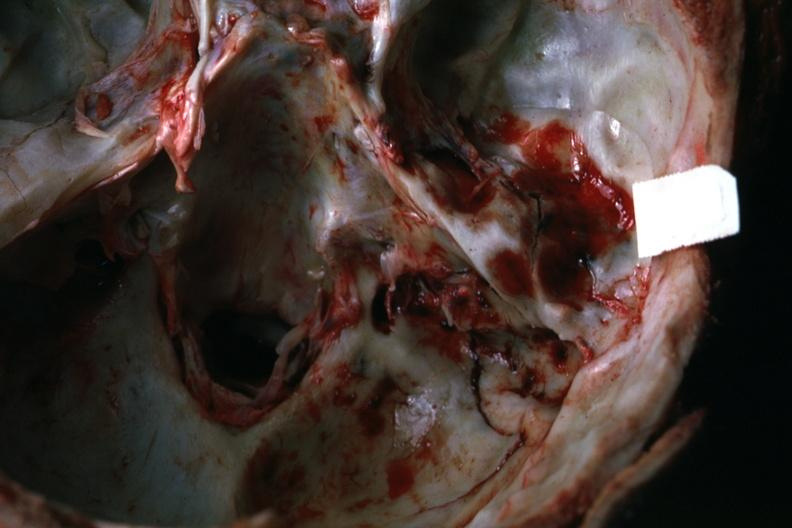how many foot does this image show view of petrous portion temporal bone rather close-up 22yo man fall?
Answer the question using a single word or phrase. 37 